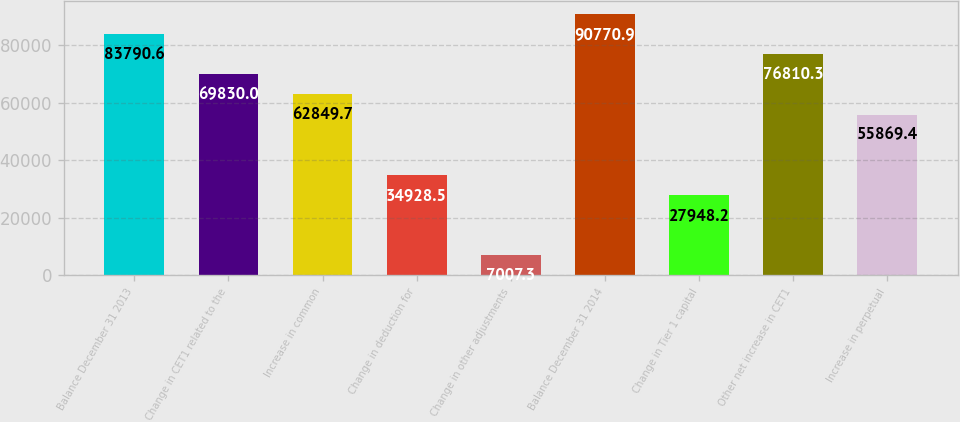Convert chart. <chart><loc_0><loc_0><loc_500><loc_500><bar_chart><fcel>Balance December 31 2013<fcel>Change in CET1 related to the<fcel>Increase in common<fcel>Change in deduction for<fcel>Change in other adjustments<fcel>Balance December 31 2014<fcel>Change in Tier 1 capital<fcel>Other net increase in CET1<fcel>Increase in perpetual<nl><fcel>83790.6<fcel>69830<fcel>62849.7<fcel>34928.5<fcel>7007.3<fcel>90770.9<fcel>27948.2<fcel>76810.3<fcel>55869.4<nl></chart> 